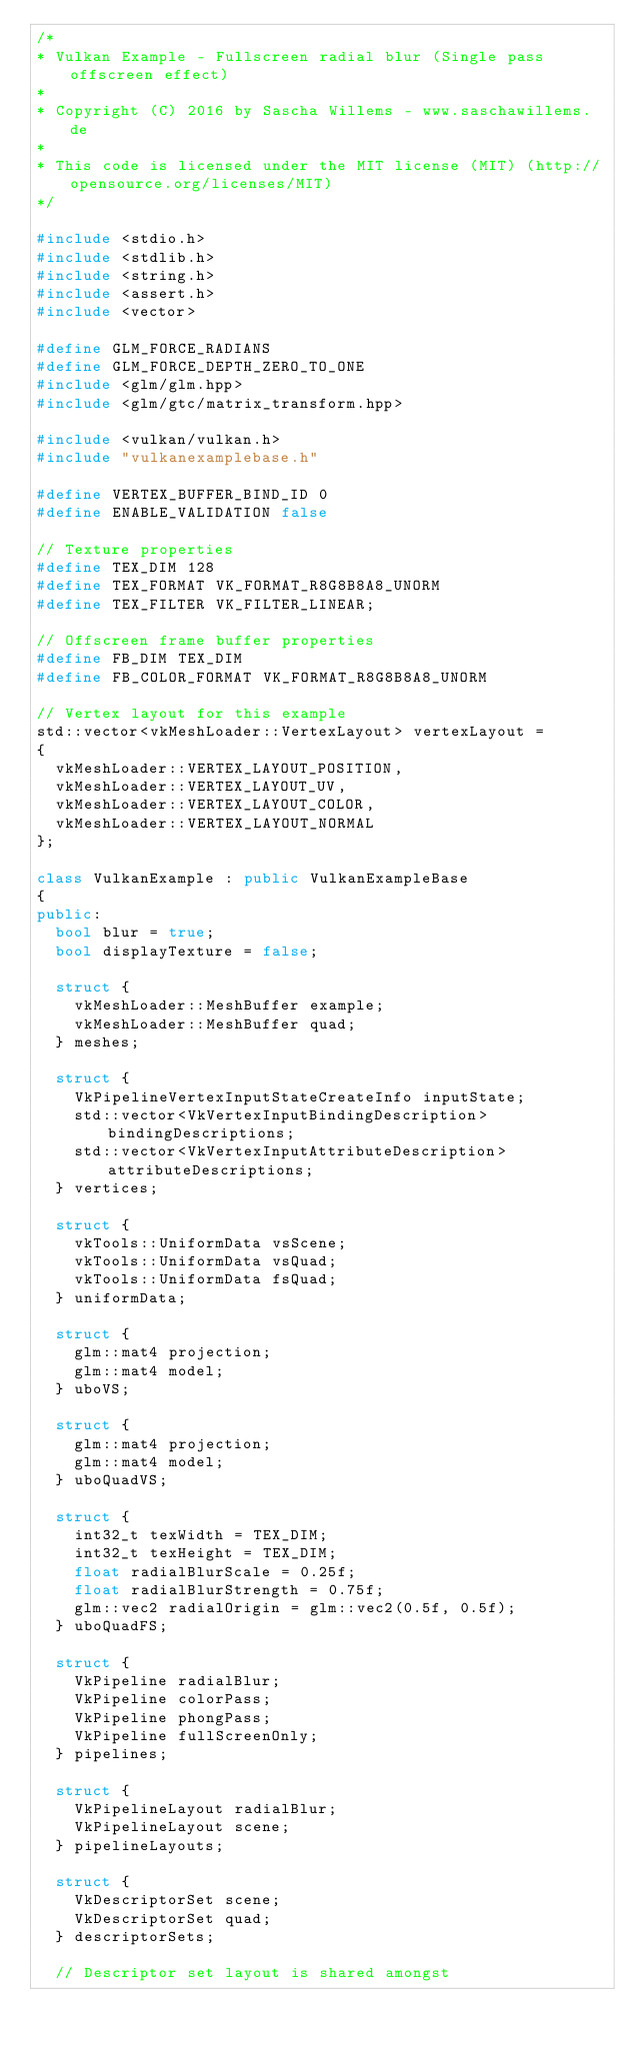Convert code to text. <code><loc_0><loc_0><loc_500><loc_500><_C++_>/*
* Vulkan Example - Fullscreen radial blur (Single pass offscreen effect)
*
* Copyright (C) 2016 by Sascha Willems - www.saschawillems.de
*
* This code is licensed under the MIT license (MIT) (http://opensource.org/licenses/MIT)
*/

#include <stdio.h>
#include <stdlib.h>
#include <string.h>
#include <assert.h>
#include <vector>

#define GLM_FORCE_RADIANS
#define GLM_FORCE_DEPTH_ZERO_TO_ONE
#include <glm/glm.hpp>
#include <glm/gtc/matrix_transform.hpp>

#include <vulkan/vulkan.h>
#include "vulkanexamplebase.h"

#define VERTEX_BUFFER_BIND_ID 0
#define ENABLE_VALIDATION false

// Texture properties
#define TEX_DIM 128
#define TEX_FORMAT VK_FORMAT_R8G8B8A8_UNORM
#define TEX_FILTER VK_FILTER_LINEAR;

// Offscreen frame buffer properties
#define FB_DIM TEX_DIM
#define FB_COLOR_FORMAT VK_FORMAT_R8G8B8A8_UNORM

// Vertex layout for this example
std::vector<vkMeshLoader::VertexLayout> vertexLayout =
{
	vkMeshLoader::VERTEX_LAYOUT_POSITION,
	vkMeshLoader::VERTEX_LAYOUT_UV,
	vkMeshLoader::VERTEX_LAYOUT_COLOR,
	vkMeshLoader::VERTEX_LAYOUT_NORMAL
};

class VulkanExample : public VulkanExampleBase
{
public:
	bool blur = true;
	bool displayTexture = false;

	struct {
		vkMeshLoader::MeshBuffer example;
		vkMeshLoader::MeshBuffer quad;
	} meshes;

	struct {
		VkPipelineVertexInputStateCreateInfo inputState;
		std::vector<VkVertexInputBindingDescription> bindingDescriptions;
		std::vector<VkVertexInputAttributeDescription> attributeDescriptions;
	} vertices;

	struct {
		vkTools::UniformData vsScene;
		vkTools::UniformData vsQuad;
		vkTools::UniformData fsQuad;
	} uniformData;

	struct {
		glm::mat4 projection;
		glm::mat4 model;
	} uboVS;

	struct {
		glm::mat4 projection;
		glm::mat4 model;
	} uboQuadVS;

	struct {
		int32_t texWidth = TEX_DIM;
		int32_t texHeight = TEX_DIM;
		float radialBlurScale = 0.25f;
		float radialBlurStrength = 0.75f;
		glm::vec2 radialOrigin = glm::vec2(0.5f, 0.5f);
	} uboQuadFS;

	struct {
		VkPipeline radialBlur;
		VkPipeline colorPass;
		VkPipeline phongPass;
		VkPipeline fullScreenOnly;
	} pipelines;

	struct {
		VkPipelineLayout radialBlur;
		VkPipelineLayout scene;
	} pipelineLayouts;

	struct {
		VkDescriptorSet scene;
		VkDescriptorSet quad;
	} descriptorSets;

	// Descriptor set layout is shared amongst</code> 